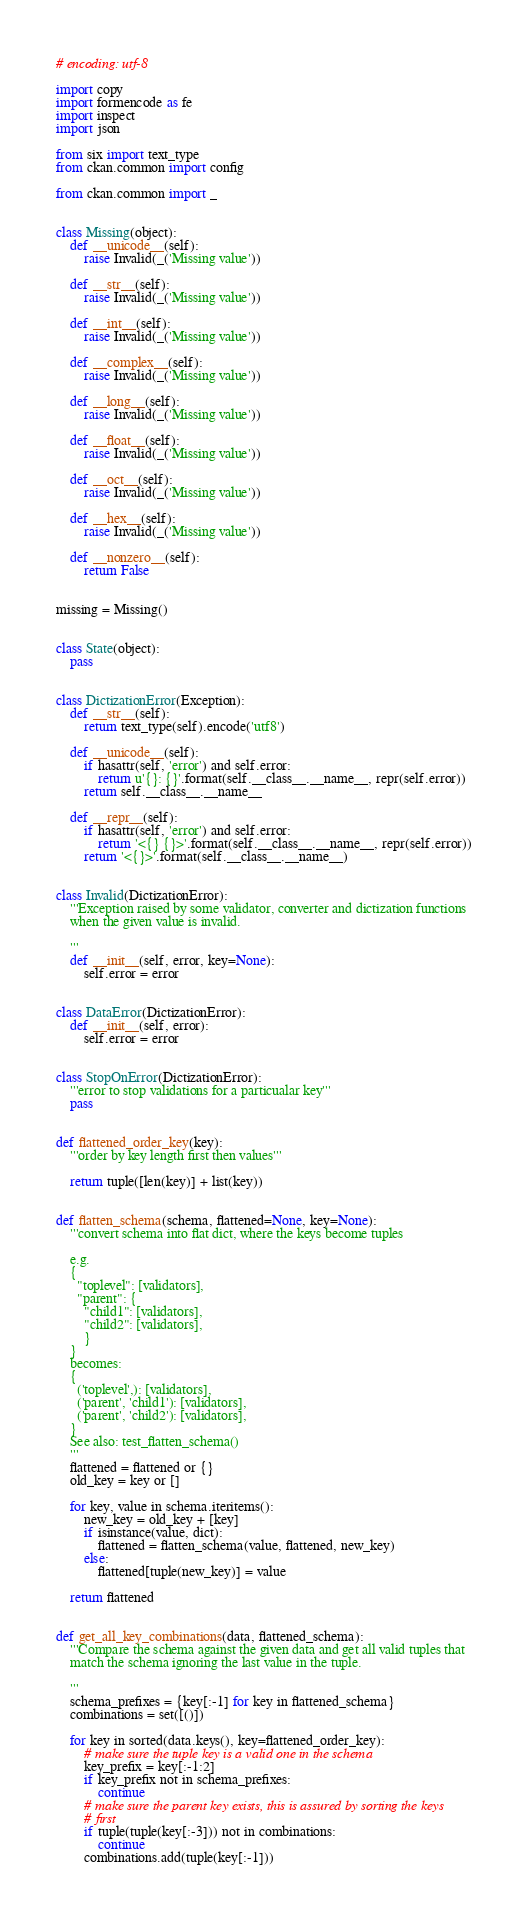Convert code to text. <code><loc_0><loc_0><loc_500><loc_500><_Python_># encoding: utf-8

import copy
import formencode as fe
import inspect
import json

from six import text_type
from ckan.common import config

from ckan.common import _


class Missing(object):
    def __unicode__(self):
        raise Invalid(_('Missing value'))

    def __str__(self):
        raise Invalid(_('Missing value'))

    def __int__(self):
        raise Invalid(_('Missing value'))

    def __complex__(self):
        raise Invalid(_('Missing value'))

    def __long__(self):
        raise Invalid(_('Missing value'))

    def __float__(self):
        raise Invalid(_('Missing value'))

    def __oct__(self):
        raise Invalid(_('Missing value'))

    def __hex__(self):
        raise Invalid(_('Missing value'))

    def __nonzero__(self):
        return False


missing = Missing()


class State(object):
    pass


class DictizationError(Exception):
    def __str__(self):
        return text_type(self).encode('utf8')

    def __unicode__(self):
        if hasattr(self, 'error') and self.error:
            return u'{}: {}'.format(self.__class__.__name__, repr(self.error))
        return self.__class__.__name__

    def __repr__(self):
        if hasattr(self, 'error') and self.error:
            return '<{} {}>'.format(self.__class__.__name__, repr(self.error))
        return '<{}>'.format(self.__class__.__name__)


class Invalid(DictizationError):
    '''Exception raised by some validator, converter and dictization functions
    when the given value is invalid.

    '''
    def __init__(self, error, key=None):
        self.error = error


class DataError(DictizationError):
    def __init__(self, error):
        self.error = error


class StopOnError(DictizationError):
    '''error to stop validations for a particualar key'''
    pass


def flattened_order_key(key):
    '''order by key length first then values'''

    return tuple([len(key)] + list(key))


def flatten_schema(schema, flattened=None, key=None):
    '''convert schema into flat dict, where the keys become tuples

    e.g.
    {
      "toplevel": [validators],
      "parent": {
        "child1": [validators],
        "child2": [validators],
        }
    }
    becomes:
    {
      ('toplevel',): [validators],
      ('parent', 'child1'): [validators],
      ('parent', 'child2'): [validators],
    }
    See also: test_flatten_schema()
    '''
    flattened = flattened or {}
    old_key = key or []

    for key, value in schema.iteritems():
        new_key = old_key + [key]
        if isinstance(value, dict):
            flattened = flatten_schema(value, flattened, new_key)
        else:
            flattened[tuple(new_key)] = value

    return flattened


def get_all_key_combinations(data, flattened_schema):
    '''Compare the schema against the given data and get all valid tuples that
    match the schema ignoring the last value in the tuple.

    '''
    schema_prefixes = {key[:-1] for key in flattened_schema}
    combinations = set([()])

    for key in sorted(data.keys(), key=flattened_order_key):
        # make sure the tuple key is a valid one in the schema
        key_prefix = key[:-1:2]
        if key_prefix not in schema_prefixes:
            continue
        # make sure the parent key exists, this is assured by sorting the keys
        # first
        if tuple(tuple(key[:-3])) not in combinations:
            continue
        combinations.add(tuple(key[:-1]))
</code> 